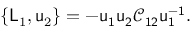<formula> <loc_0><loc_0><loc_500><loc_500>\{ L _ { 1 } , u _ { 2 } \} = - u _ { 1 } u _ { 2 } \mathcal { C } _ { 1 2 } u _ { 1 } ^ { - 1 } .</formula> 